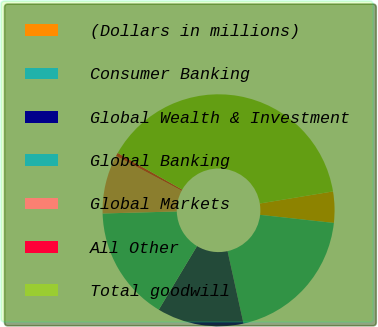<chart> <loc_0><loc_0><loc_500><loc_500><pie_chart><fcel>(Dollars in millions)<fcel>Consumer Banking<fcel>Global Wealth & Investment<fcel>Global Banking<fcel>Global Markets<fcel>All Other<fcel>Total goodwill<nl><fcel>4.34%<fcel>19.81%<fcel>12.07%<fcel>15.94%<fcel>8.2%<fcel>0.47%<fcel>39.16%<nl></chart> 